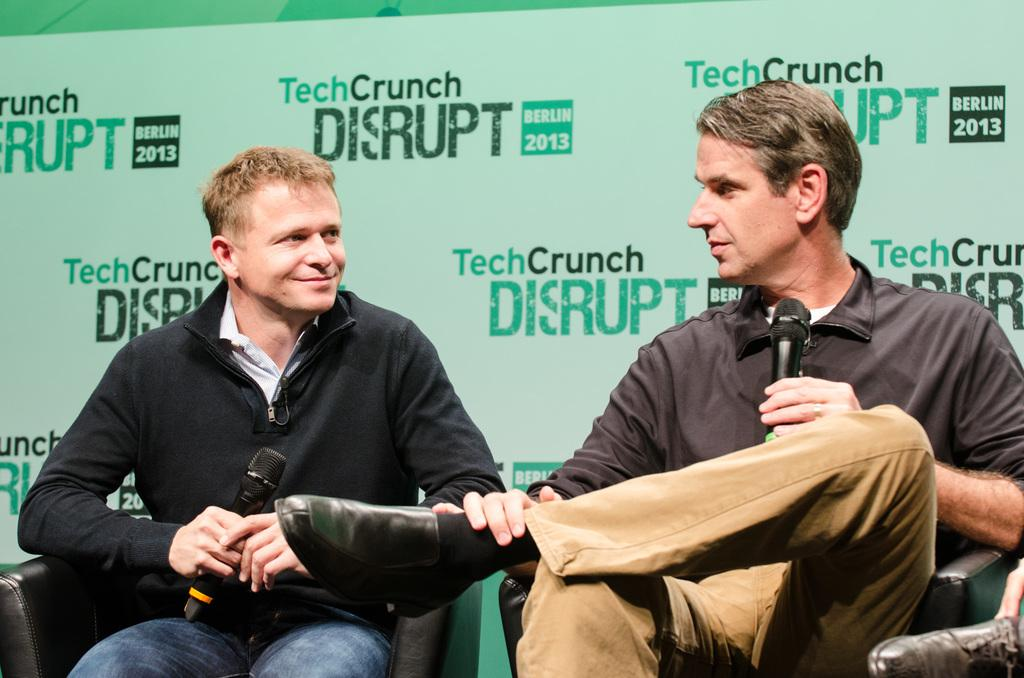How many people are in the image? There are two men in the image. What are the men doing in the image? The men are sitting on chairs and holding microphones. What can be seen in the background of the image? There is a hoarding in the background of the image. What is the name of the wound on the man's arm in the image? There is no wound visible on any of the men's arms in the image. How many chairs are present in the image? The image shows two men sitting on chairs, so there are two chairs present. 